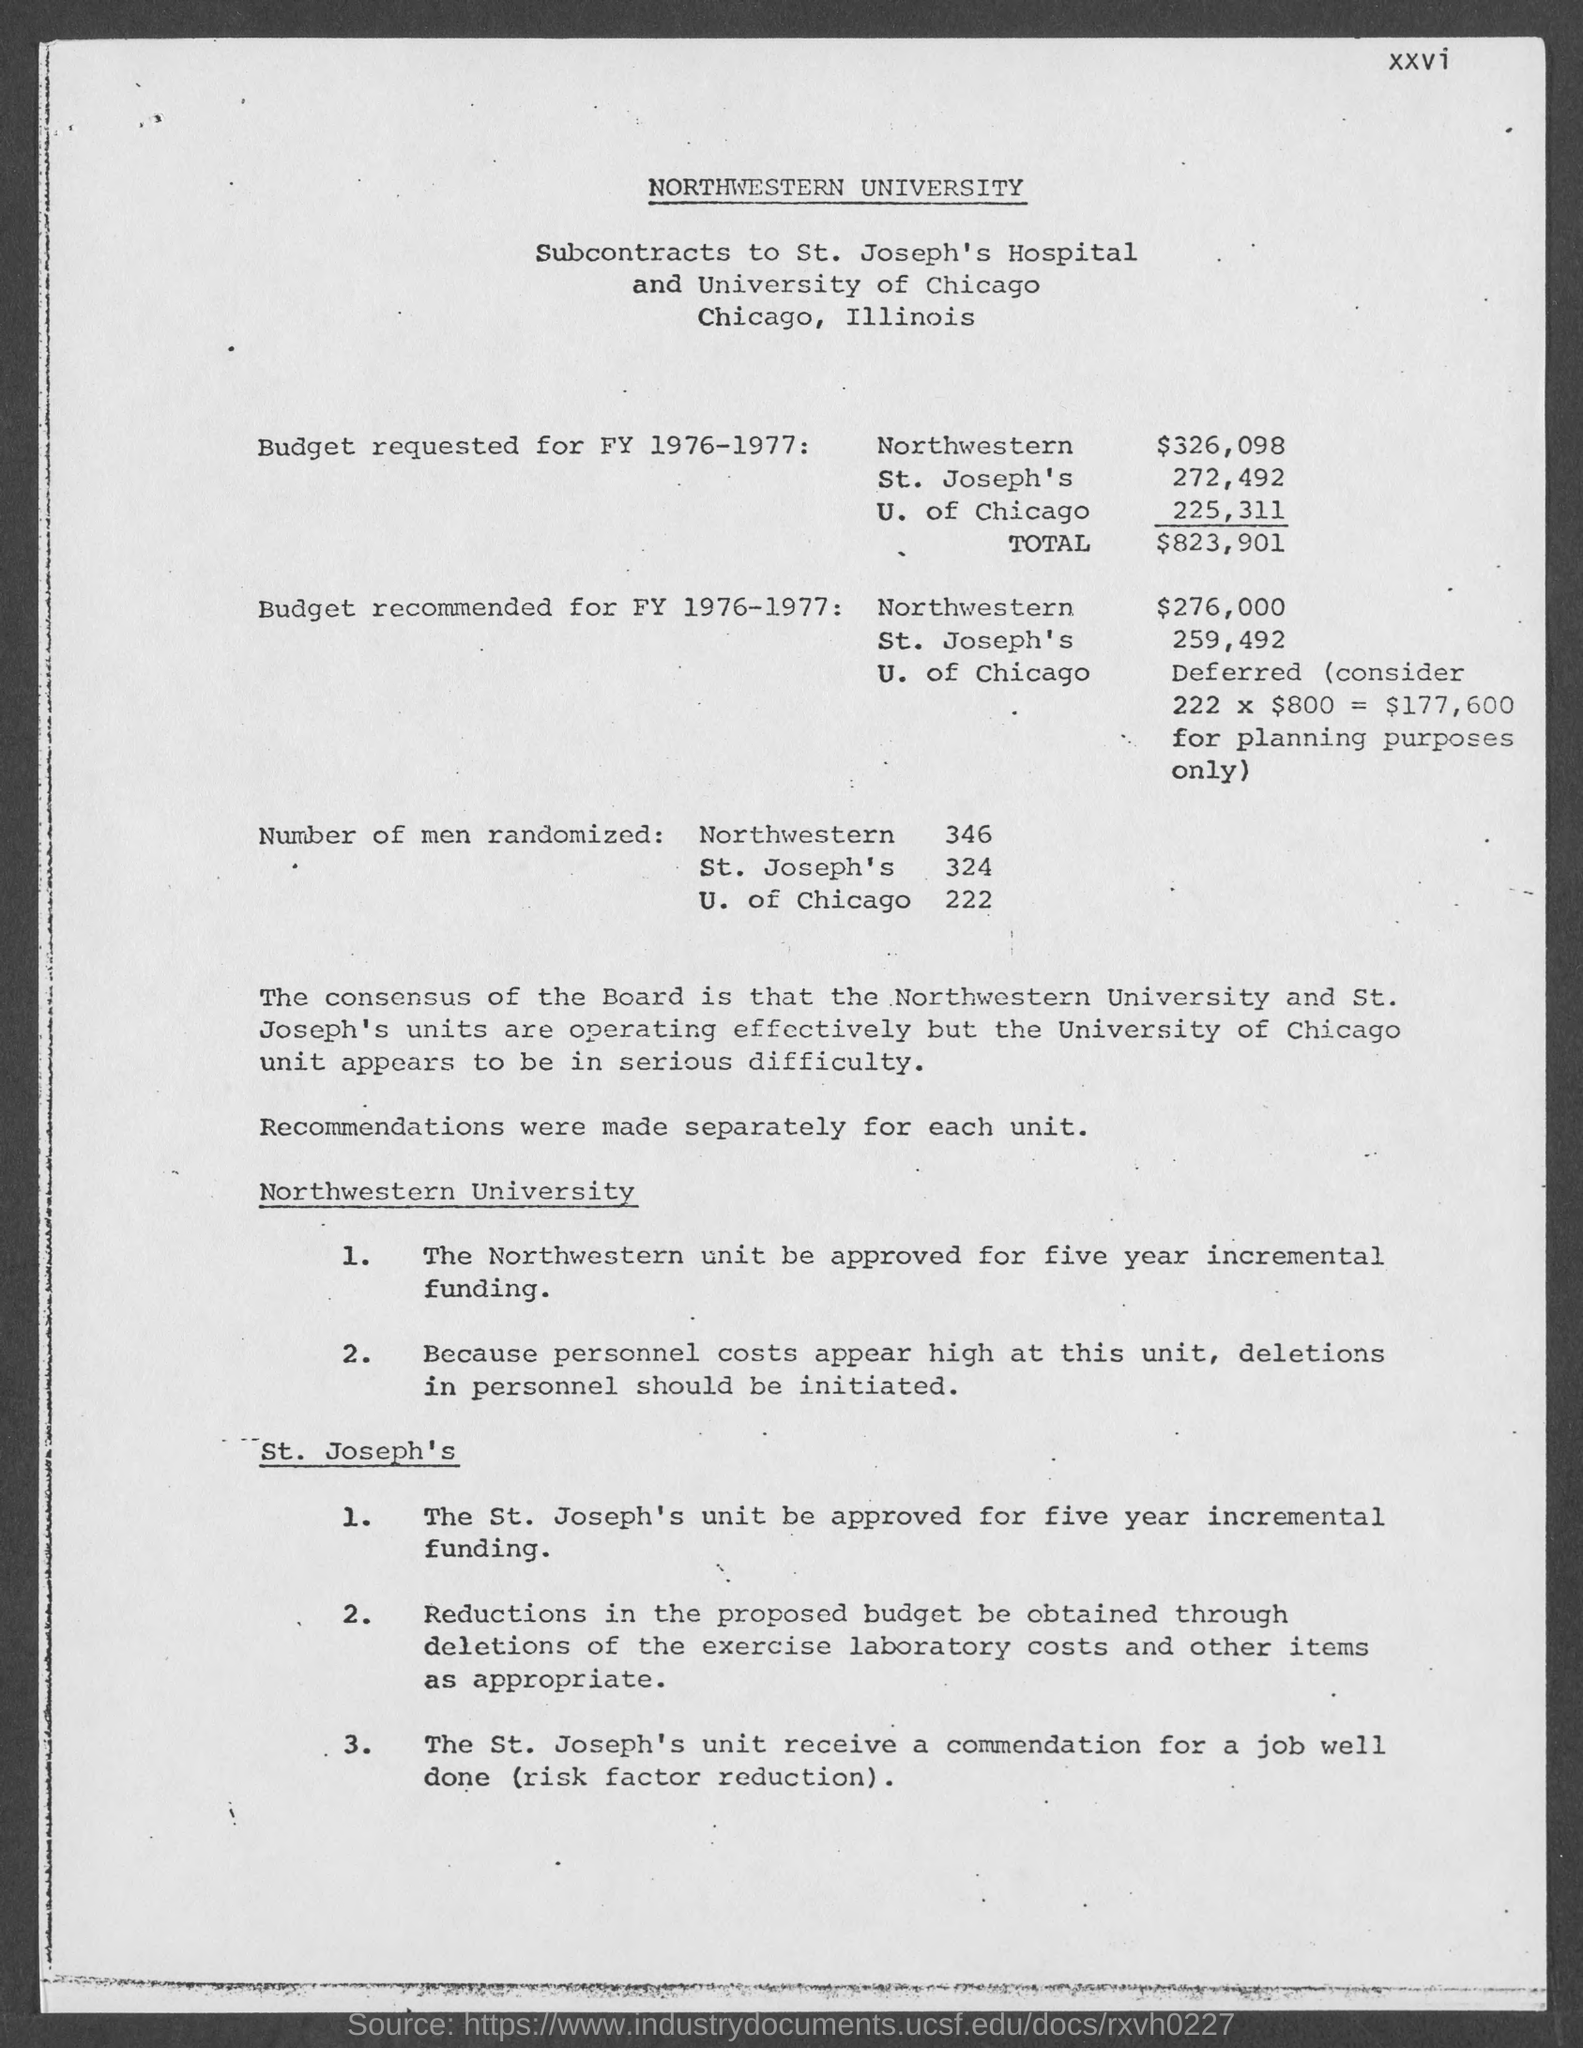What is the budget requested for fy 1976- 1977 for northwestern?
Your answer should be very brief. $326,098. What is the budget requested for fy 1976-1977 for st.joseph's ?
Provide a short and direct response. 272,492. What is the budget requested for fy 1976-1977 for u. of chicago ?
Your answer should be very brief. $225,311. What is the budget requested for fy 1976-1977 in total?
Provide a succinct answer. $823,901. What is the budget recommended for fy 1976-1977 for northwestern ?
Provide a succinct answer. $276,000. What is the budget recommended for fy 1976-1977 for st. joseph's ?
Offer a terse response. 259,492. How many number of men are randomized in northwestern ?
Offer a very short reply. 346. How many number of men are randomized in st. joseph's ?
Provide a succinct answer. 324. How many number of men are randomized in u. of chicago ?
Provide a short and direct response. 222. 